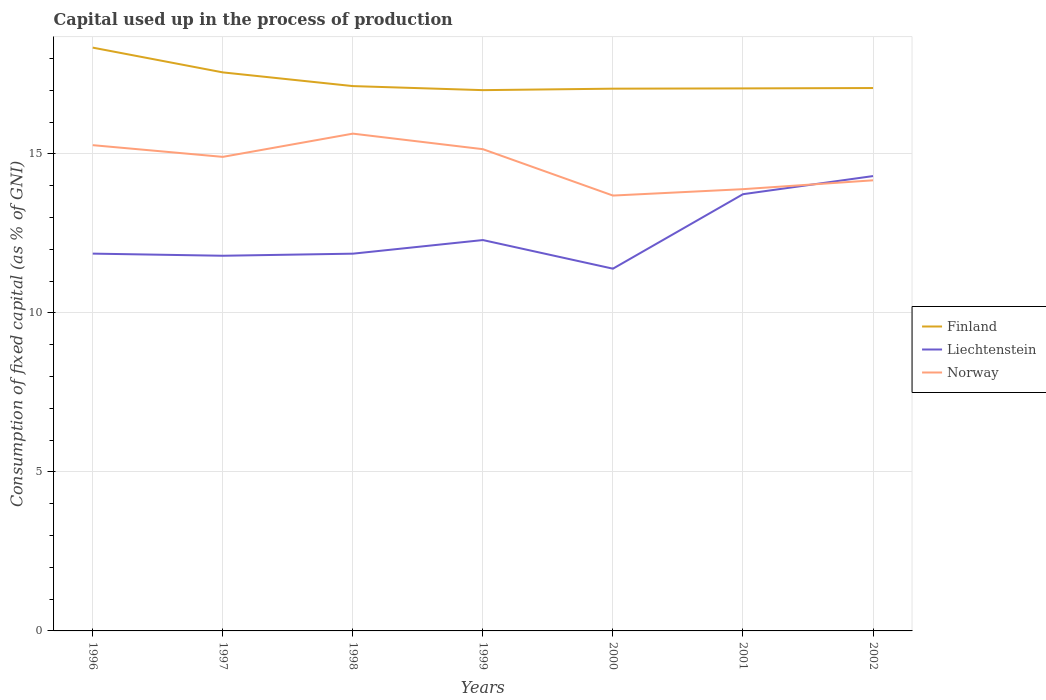Is the number of lines equal to the number of legend labels?
Your answer should be compact. Yes. Across all years, what is the maximum capital used up in the process of production in Finland?
Ensure brevity in your answer.  17.01. What is the total capital used up in the process of production in Liechtenstein in the graph?
Provide a short and direct response. -2.44. What is the difference between the highest and the second highest capital used up in the process of production in Norway?
Keep it short and to the point. 1.95. What is the difference between the highest and the lowest capital used up in the process of production in Liechtenstein?
Ensure brevity in your answer.  2. What is the difference between two consecutive major ticks on the Y-axis?
Provide a succinct answer. 5. Are the values on the major ticks of Y-axis written in scientific E-notation?
Make the answer very short. No. Does the graph contain any zero values?
Your response must be concise. No. Does the graph contain grids?
Provide a succinct answer. Yes. What is the title of the graph?
Your answer should be very brief. Capital used up in the process of production. What is the label or title of the X-axis?
Your answer should be compact. Years. What is the label or title of the Y-axis?
Give a very brief answer. Consumption of fixed capital (as % of GNI). What is the Consumption of fixed capital (as % of GNI) of Finland in 1996?
Provide a short and direct response. 18.34. What is the Consumption of fixed capital (as % of GNI) in Liechtenstein in 1996?
Give a very brief answer. 11.86. What is the Consumption of fixed capital (as % of GNI) in Norway in 1996?
Offer a terse response. 15.28. What is the Consumption of fixed capital (as % of GNI) in Finland in 1997?
Keep it short and to the point. 17.56. What is the Consumption of fixed capital (as % of GNI) of Liechtenstein in 1997?
Make the answer very short. 11.8. What is the Consumption of fixed capital (as % of GNI) of Norway in 1997?
Your answer should be very brief. 14.91. What is the Consumption of fixed capital (as % of GNI) of Finland in 1998?
Give a very brief answer. 17.13. What is the Consumption of fixed capital (as % of GNI) in Liechtenstein in 1998?
Provide a short and direct response. 11.86. What is the Consumption of fixed capital (as % of GNI) in Norway in 1998?
Make the answer very short. 15.64. What is the Consumption of fixed capital (as % of GNI) in Finland in 1999?
Provide a short and direct response. 17.01. What is the Consumption of fixed capital (as % of GNI) of Liechtenstein in 1999?
Ensure brevity in your answer.  12.29. What is the Consumption of fixed capital (as % of GNI) in Norway in 1999?
Offer a terse response. 15.15. What is the Consumption of fixed capital (as % of GNI) of Finland in 2000?
Offer a terse response. 17.05. What is the Consumption of fixed capital (as % of GNI) in Liechtenstein in 2000?
Ensure brevity in your answer.  11.39. What is the Consumption of fixed capital (as % of GNI) of Norway in 2000?
Make the answer very short. 13.69. What is the Consumption of fixed capital (as % of GNI) in Finland in 2001?
Your answer should be compact. 17.06. What is the Consumption of fixed capital (as % of GNI) of Liechtenstein in 2001?
Give a very brief answer. 13.73. What is the Consumption of fixed capital (as % of GNI) of Norway in 2001?
Ensure brevity in your answer.  13.89. What is the Consumption of fixed capital (as % of GNI) in Finland in 2002?
Offer a very short reply. 17.07. What is the Consumption of fixed capital (as % of GNI) of Liechtenstein in 2002?
Provide a short and direct response. 14.3. What is the Consumption of fixed capital (as % of GNI) in Norway in 2002?
Make the answer very short. 14.17. Across all years, what is the maximum Consumption of fixed capital (as % of GNI) of Finland?
Your answer should be very brief. 18.34. Across all years, what is the maximum Consumption of fixed capital (as % of GNI) in Liechtenstein?
Your answer should be very brief. 14.3. Across all years, what is the maximum Consumption of fixed capital (as % of GNI) of Norway?
Give a very brief answer. 15.64. Across all years, what is the minimum Consumption of fixed capital (as % of GNI) of Finland?
Make the answer very short. 17.01. Across all years, what is the minimum Consumption of fixed capital (as % of GNI) in Liechtenstein?
Give a very brief answer. 11.39. Across all years, what is the minimum Consumption of fixed capital (as % of GNI) in Norway?
Your answer should be very brief. 13.69. What is the total Consumption of fixed capital (as % of GNI) in Finland in the graph?
Offer a terse response. 121.23. What is the total Consumption of fixed capital (as % of GNI) in Liechtenstein in the graph?
Your response must be concise. 87.24. What is the total Consumption of fixed capital (as % of GNI) of Norway in the graph?
Provide a short and direct response. 102.72. What is the difference between the Consumption of fixed capital (as % of GNI) in Finland in 1996 and that in 1997?
Offer a very short reply. 0.78. What is the difference between the Consumption of fixed capital (as % of GNI) in Liechtenstein in 1996 and that in 1997?
Offer a very short reply. 0.07. What is the difference between the Consumption of fixed capital (as % of GNI) in Norway in 1996 and that in 1997?
Your response must be concise. 0.37. What is the difference between the Consumption of fixed capital (as % of GNI) of Finland in 1996 and that in 1998?
Your response must be concise. 1.21. What is the difference between the Consumption of fixed capital (as % of GNI) of Liechtenstein in 1996 and that in 1998?
Ensure brevity in your answer.  0. What is the difference between the Consumption of fixed capital (as % of GNI) in Norway in 1996 and that in 1998?
Give a very brief answer. -0.36. What is the difference between the Consumption of fixed capital (as % of GNI) of Finland in 1996 and that in 1999?
Give a very brief answer. 1.34. What is the difference between the Consumption of fixed capital (as % of GNI) of Liechtenstein in 1996 and that in 1999?
Keep it short and to the point. -0.43. What is the difference between the Consumption of fixed capital (as % of GNI) in Norway in 1996 and that in 1999?
Provide a short and direct response. 0.13. What is the difference between the Consumption of fixed capital (as % of GNI) in Finland in 1996 and that in 2000?
Give a very brief answer. 1.29. What is the difference between the Consumption of fixed capital (as % of GNI) in Liechtenstein in 1996 and that in 2000?
Your answer should be very brief. 0.47. What is the difference between the Consumption of fixed capital (as % of GNI) in Norway in 1996 and that in 2000?
Your answer should be compact. 1.58. What is the difference between the Consumption of fixed capital (as % of GNI) in Finland in 1996 and that in 2001?
Your response must be concise. 1.28. What is the difference between the Consumption of fixed capital (as % of GNI) in Liechtenstein in 1996 and that in 2001?
Offer a very short reply. -1.87. What is the difference between the Consumption of fixed capital (as % of GNI) in Norway in 1996 and that in 2001?
Give a very brief answer. 1.38. What is the difference between the Consumption of fixed capital (as % of GNI) in Finland in 1996 and that in 2002?
Your response must be concise. 1.27. What is the difference between the Consumption of fixed capital (as % of GNI) of Liechtenstein in 1996 and that in 2002?
Give a very brief answer. -2.44. What is the difference between the Consumption of fixed capital (as % of GNI) in Norway in 1996 and that in 2002?
Make the answer very short. 1.11. What is the difference between the Consumption of fixed capital (as % of GNI) of Finland in 1997 and that in 1998?
Provide a succinct answer. 0.43. What is the difference between the Consumption of fixed capital (as % of GNI) of Liechtenstein in 1997 and that in 1998?
Give a very brief answer. -0.07. What is the difference between the Consumption of fixed capital (as % of GNI) in Norway in 1997 and that in 1998?
Ensure brevity in your answer.  -0.73. What is the difference between the Consumption of fixed capital (as % of GNI) in Finland in 1997 and that in 1999?
Offer a very short reply. 0.56. What is the difference between the Consumption of fixed capital (as % of GNI) in Liechtenstein in 1997 and that in 1999?
Provide a succinct answer. -0.49. What is the difference between the Consumption of fixed capital (as % of GNI) in Norway in 1997 and that in 1999?
Offer a very short reply. -0.24. What is the difference between the Consumption of fixed capital (as % of GNI) in Finland in 1997 and that in 2000?
Provide a short and direct response. 0.51. What is the difference between the Consumption of fixed capital (as % of GNI) in Liechtenstein in 1997 and that in 2000?
Your answer should be compact. 0.41. What is the difference between the Consumption of fixed capital (as % of GNI) of Norway in 1997 and that in 2000?
Keep it short and to the point. 1.22. What is the difference between the Consumption of fixed capital (as % of GNI) in Finland in 1997 and that in 2001?
Give a very brief answer. 0.5. What is the difference between the Consumption of fixed capital (as % of GNI) in Liechtenstein in 1997 and that in 2001?
Give a very brief answer. -1.94. What is the difference between the Consumption of fixed capital (as % of GNI) of Norway in 1997 and that in 2001?
Your answer should be very brief. 1.02. What is the difference between the Consumption of fixed capital (as % of GNI) of Finland in 1997 and that in 2002?
Keep it short and to the point. 0.49. What is the difference between the Consumption of fixed capital (as % of GNI) of Liechtenstein in 1997 and that in 2002?
Your response must be concise. -2.51. What is the difference between the Consumption of fixed capital (as % of GNI) of Norway in 1997 and that in 2002?
Your answer should be compact. 0.74. What is the difference between the Consumption of fixed capital (as % of GNI) of Finland in 1998 and that in 1999?
Offer a very short reply. 0.13. What is the difference between the Consumption of fixed capital (as % of GNI) of Liechtenstein in 1998 and that in 1999?
Your response must be concise. -0.43. What is the difference between the Consumption of fixed capital (as % of GNI) of Norway in 1998 and that in 1999?
Give a very brief answer. 0.49. What is the difference between the Consumption of fixed capital (as % of GNI) in Finland in 1998 and that in 2000?
Make the answer very short. 0.08. What is the difference between the Consumption of fixed capital (as % of GNI) in Liechtenstein in 1998 and that in 2000?
Provide a succinct answer. 0.47. What is the difference between the Consumption of fixed capital (as % of GNI) in Norway in 1998 and that in 2000?
Your answer should be very brief. 1.95. What is the difference between the Consumption of fixed capital (as % of GNI) in Finland in 1998 and that in 2001?
Offer a terse response. 0.07. What is the difference between the Consumption of fixed capital (as % of GNI) in Liechtenstein in 1998 and that in 2001?
Keep it short and to the point. -1.87. What is the difference between the Consumption of fixed capital (as % of GNI) of Norway in 1998 and that in 2001?
Your answer should be compact. 1.75. What is the difference between the Consumption of fixed capital (as % of GNI) in Finland in 1998 and that in 2002?
Provide a short and direct response. 0.06. What is the difference between the Consumption of fixed capital (as % of GNI) of Liechtenstein in 1998 and that in 2002?
Ensure brevity in your answer.  -2.44. What is the difference between the Consumption of fixed capital (as % of GNI) of Norway in 1998 and that in 2002?
Provide a succinct answer. 1.47. What is the difference between the Consumption of fixed capital (as % of GNI) of Finland in 1999 and that in 2000?
Your answer should be very brief. -0.05. What is the difference between the Consumption of fixed capital (as % of GNI) in Norway in 1999 and that in 2000?
Your response must be concise. 1.46. What is the difference between the Consumption of fixed capital (as % of GNI) of Finland in 1999 and that in 2001?
Offer a terse response. -0.05. What is the difference between the Consumption of fixed capital (as % of GNI) in Liechtenstein in 1999 and that in 2001?
Your response must be concise. -1.44. What is the difference between the Consumption of fixed capital (as % of GNI) in Norway in 1999 and that in 2001?
Offer a terse response. 1.26. What is the difference between the Consumption of fixed capital (as % of GNI) of Finland in 1999 and that in 2002?
Provide a succinct answer. -0.07. What is the difference between the Consumption of fixed capital (as % of GNI) of Liechtenstein in 1999 and that in 2002?
Ensure brevity in your answer.  -2.01. What is the difference between the Consumption of fixed capital (as % of GNI) of Finland in 2000 and that in 2001?
Your answer should be compact. -0.01. What is the difference between the Consumption of fixed capital (as % of GNI) of Liechtenstein in 2000 and that in 2001?
Your answer should be compact. -2.34. What is the difference between the Consumption of fixed capital (as % of GNI) of Norway in 2000 and that in 2001?
Offer a terse response. -0.2. What is the difference between the Consumption of fixed capital (as % of GNI) of Finland in 2000 and that in 2002?
Your answer should be very brief. -0.02. What is the difference between the Consumption of fixed capital (as % of GNI) of Liechtenstein in 2000 and that in 2002?
Your answer should be compact. -2.91. What is the difference between the Consumption of fixed capital (as % of GNI) of Norway in 2000 and that in 2002?
Make the answer very short. -0.48. What is the difference between the Consumption of fixed capital (as % of GNI) of Finland in 2001 and that in 2002?
Offer a very short reply. -0.01. What is the difference between the Consumption of fixed capital (as % of GNI) in Liechtenstein in 2001 and that in 2002?
Make the answer very short. -0.57. What is the difference between the Consumption of fixed capital (as % of GNI) in Norway in 2001 and that in 2002?
Provide a succinct answer. -0.28. What is the difference between the Consumption of fixed capital (as % of GNI) in Finland in 1996 and the Consumption of fixed capital (as % of GNI) in Liechtenstein in 1997?
Provide a short and direct response. 6.54. What is the difference between the Consumption of fixed capital (as % of GNI) in Finland in 1996 and the Consumption of fixed capital (as % of GNI) in Norway in 1997?
Offer a terse response. 3.44. What is the difference between the Consumption of fixed capital (as % of GNI) in Liechtenstein in 1996 and the Consumption of fixed capital (as % of GNI) in Norway in 1997?
Your answer should be compact. -3.04. What is the difference between the Consumption of fixed capital (as % of GNI) in Finland in 1996 and the Consumption of fixed capital (as % of GNI) in Liechtenstein in 1998?
Your answer should be compact. 6.48. What is the difference between the Consumption of fixed capital (as % of GNI) in Finland in 1996 and the Consumption of fixed capital (as % of GNI) in Norway in 1998?
Give a very brief answer. 2.7. What is the difference between the Consumption of fixed capital (as % of GNI) of Liechtenstein in 1996 and the Consumption of fixed capital (as % of GNI) of Norway in 1998?
Ensure brevity in your answer.  -3.77. What is the difference between the Consumption of fixed capital (as % of GNI) of Finland in 1996 and the Consumption of fixed capital (as % of GNI) of Liechtenstein in 1999?
Offer a terse response. 6.05. What is the difference between the Consumption of fixed capital (as % of GNI) of Finland in 1996 and the Consumption of fixed capital (as % of GNI) of Norway in 1999?
Give a very brief answer. 3.19. What is the difference between the Consumption of fixed capital (as % of GNI) of Liechtenstein in 1996 and the Consumption of fixed capital (as % of GNI) of Norway in 1999?
Keep it short and to the point. -3.28. What is the difference between the Consumption of fixed capital (as % of GNI) of Finland in 1996 and the Consumption of fixed capital (as % of GNI) of Liechtenstein in 2000?
Provide a short and direct response. 6.95. What is the difference between the Consumption of fixed capital (as % of GNI) in Finland in 1996 and the Consumption of fixed capital (as % of GNI) in Norway in 2000?
Give a very brief answer. 4.65. What is the difference between the Consumption of fixed capital (as % of GNI) of Liechtenstein in 1996 and the Consumption of fixed capital (as % of GNI) of Norway in 2000?
Provide a succinct answer. -1.83. What is the difference between the Consumption of fixed capital (as % of GNI) in Finland in 1996 and the Consumption of fixed capital (as % of GNI) in Liechtenstein in 2001?
Keep it short and to the point. 4.61. What is the difference between the Consumption of fixed capital (as % of GNI) in Finland in 1996 and the Consumption of fixed capital (as % of GNI) in Norway in 2001?
Your answer should be very brief. 4.45. What is the difference between the Consumption of fixed capital (as % of GNI) of Liechtenstein in 1996 and the Consumption of fixed capital (as % of GNI) of Norway in 2001?
Ensure brevity in your answer.  -2.03. What is the difference between the Consumption of fixed capital (as % of GNI) in Finland in 1996 and the Consumption of fixed capital (as % of GNI) in Liechtenstein in 2002?
Give a very brief answer. 4.04. What is the difference between the Consumption of fixed capital (as % of GNI) of Finland in 1996 and the Consumption of fixed capital (as % of GNI) of Norway in 2002?
Your response must be concise. 4.17. What is the difference between the Consumption of fixed capital (as % of GNI) of Liechtenstein in 1996 and the Consumption of fixed capital (as % of GNI) of Norway in 2002?
Ensure brevity in your answer.  -2.31. What is the difference between the Consumption of fixed capital (as % of GNI) in Finland in 1997 and the Consumption of fixed capital (as % of GNI) in Liechtenstein in 1998?
Provide a short and direct response. 5.7. What is the difference between the Consumption of fixed capital (as % of GNI) in Finland in 1997 and the Consumption of fixed capital (as % of GNI) in Norway in 1998?
Provide a short and direct response. 1.93. What is the difference between the Consumption of fixed capital (as % of GNI) of Liechtenstein in 1997 and the Consumption of fixed capital (as % of GNI) of Norway in 1998?
Your answer should be very brief. -3.84. What is the difference between the Consumption of fixed capital (as % of GNI) of Finland in 1997 and the Consumption of fixed capital (as % of GNI) of Liechtenstein in 1999?
Keep it short and to the point. 5.27. What is the difference between the Consumption of fixed capital (as % of GNI) in Finland in 1997 and the Consumption of fixed capital (as % of GNI) in Norway in 1999?
Your response must be concise. 2.42. What is the difference between the Consumption of fixed capital (as % of GNI) in Liechtenstein in 1997 and the Consumption of fixed capital (as % of GNI) in Norway in 1999?
Give a very brief answer. -3.35. What is the difference between the Consumption of fixed capital (as % of GNI) of Finland in 1997 and the Consumption of fixed capital (as % of GNI) of Liechtenstein in 2000?
Offer a terse response. 6.17. What is the difference between the Consumption of fixed capital (as % of GNI) of Finland in 1997 and the Consumption of fixed capital (as % of GNI) of Norway in 2000?
Provide a short and direct response. 3.87. What is the difference between the Consumption of fixed capital (as % of GNI) of Liechtenstein in 1997 and the Consumption of fixed capital (as % of GNI) of Norway in 2000?
Your answer should be very brief. -1.89. What is the difference between the Consumption of fixed capital (as % of GNI) in Finland in 1997 and the Consumption of fixed capital (as % of GNI) in Liechtenstein in 2001?
Provide a succinct answer. 3.83. What is the difference between the Consumption of fixed capital (as % of GNI) of Finland in 1997 and the Consumption of fixed capital (as % of GNI) of Norway in 2001?
Make the answer very short. 3.67. What is the difference between the Consumption of fixed capital (as % of GNI) of Liechtenstein in 1997 and the Consumption of fixed capital (as % of GNI) of Norway in 2001?
Keep it short and to the point. -2.09. What is the difference between the Consumption of fixed capital (as % of GNI) in Finland in 1997 and the Consumption of fixed capital (as % of GNI) in Liechtenstein in 2002?
Provide a short and direct response. 3.26. What is the difference between the Consumption of fixed capital (as % of GNI) in Finland in 1997 and the Consumption of fixed capital (as % of GNI) in Norway in 2002?
Ensure brevity in your answer.  3.39. What is the difference between the Consumption of fixed capital (as % of GNI) of Liechtenstein in 1997 and the Consumption of fixed capital (as % of GNI) of Norway in 2002?
Give a very brief answer. -2.37. What is the difference between the Consumption of fixed capital (as % of GNI) of Finland in 1998 and the Consumption of fixed capital (as % of GNI) of Liechtenstein in 1999?
Give a very brief answer. 4.84. What is the difference between the Consumption of fixed capital (as % of GNI) in Finland in 1998 and the Consumption of fixed capital (as % of GNI) in Norway in 1999?
Your answer should be compact. 1.98. What is the difference between the Consumption of fixed capital (as % of GNI) of Liechtenstein in 1998 and the Consumption of fixed capital (as % of GNI) of Norway in 1999?
Your response must be concise. -3.29. What is the difference between the Consumption of fixed capital (as % of GNI) of Finland in 1998 and the Consumption of fixed capital (as % of GNI) of Liechtenstein in 2000?
Offer a very short reply. 5.74. What is the difference between the Consumption of fixed capital (as % of GNI) of Finland in 1998 and the Consumption of fixed capital (as % of GNI) of Norway in 2000?
Keep it short and to the point. 3.44. What is the difference between the Consumption of fixed capital (as % of GNI) in Liechtenstein in 1998 and the Consumption of fixed capital (as % of GNI) in Norway in 2000?
Provide a short and direct response. -1.83. What is the difference between the Consumption of fixed capital (as % of GNI) in Finland in 1998 and the Consumption of fixed capital (as % of GNI) in Liechtenstein in 2001?
Offer a very short reply. 3.4. What is the difference between the Consumption of fixed capital (as % of GNI) in Finland in 1998 and the Consumption of fixed capital (as % of GNI) in Norway in 2001?
Offer a very short reply. 3.24. What is the difference between the Consumption of fixed capital (as % of GNI) in Liechtenstein in 1998 and the Consumption of fixed capital (as % of GNI) in Norway in 2001?
Give a very brief answer. -2.03. What is the difference between the Consumption of fixed capital (as % of GNI) of Finland in 1998 and the Consumption of fixed capital (as % of GNI) of Liechtenstein in 2002?
Provide a succinct answer. 2.83. What is the difference between the Consumption of fixed capital (as % of GNI) in Finland in 1998 and the Consumption of fixed capital (as % of GNI) in Norway in 2002?
Keep it short and to the point. 2.96. What is the difference between the Consumption of fixed capital (as % of GNI) of Liechtenstein in 1998 and the Consumption of fixed capital (as % of GNI) of Norway in 2002?
Provide a short and direct response. -2.31. What is the difference between the Consumption of fixed capital (as % of GNI) in Finland in 1999 and the Consumption of fixed capital (as % of GNI) in Liechtenstein in 2000?
Make the answer very short. 5.61. What is the difference between the Consumption of fixed capital (as % of GNI) in Finland in 1999 and the Consumption of fixed capital (as % of GNI) in Norway in 2000?
Provide a short and direct response. 3.32. What is the difference between the Consumption of fixed capital (as % of GNI) of Liechtenstein in 1999 and the Consumption of fixed capital (as % of GNI) of Norway in 2000?
Keep it short and to the point. -1.4. What is the difference between the Consumption of fixed capital (as % of GNI) in Finland in 1999 and the Consumption of fixed capital (as % of GNI) in Liechtenstein in 2001?
Your answer should be very brief. 3.27. What is the difference between the Consumption of fixed capital (as % of GNI) of Finland in 1999 and the Consumption of fixed capital (as % of GNI) of Norway in 2001?
Provide a short and direct response. 3.11. What is the difference between the Consumption of fixed capital (as % of GNI) of Liechtenstein in 1999 and the Consumption of fixed capital (as % of GNI) of Norway in 2001?
Keep it short and to the point. -1.6. What is the difference between the Consumption of fixed capital (as % of GNI) in Finland in 1999 and the Consumption of fixed capital (as % of GNI) in Liechtenstein in 2002?
Keep it short and to the point. 2.7. What is the difference between the Consumption of fixed capital (as % of GNI) of Finland in 1999 and the Consumption of fixed capital (as % of GNI) of Norway in 2002?
Give a very brief answer. 2.84. What is the difference between the Consumption of fixed capital (as % of GNI) of Liechtenstein in 1999 and the Consumption of fixed capital (as % of GNI) of Norway in 2002?
Your answer should be very brief. -1.88. What is the difference between the Consumption of fixed capital (as % of GNI) of Finland in 2000 and the Consumption of fixed capital (as % of GNI) of Liechtenstein in 2001?
Offer a terse response. 3.32. What is the difference between the Consumption of fixed capital (as % of GNI) in Finland in 2000 and the Consumption of fixed capital (as % of GNI) in Norway in 2001?
Provide a short and direct response. 3.16. What is the difference between the Consumption of fixed capital (as % of GNI) of Liechtenstein in 2000 and the Consumption of fixed capital (as % of GNI) of Norway in 2001?
Your response must be concise. -2.5. What is the difference between the Consumption of fixed capital (as % of GNI) in Finland in 2000 and the Consumption of fixed capital (as % of GNI) in Liechtenstein in 2002?
Offer a terse response. 2.75. What is the difference between the Consumption of fixed capital (as % of GNI) of Finland in 2000 and the Consumption of fixed capital (as % of GNI) of Norway in 2002?
Keep it short and to the point. 2.88. What is the difference between the Consumption of fixed capital (as % of GNI) of Liechtenstein in 2000 and the Consumption of fixed capital (as % of GNI) of Norway in 2002?
Offer a terse response. -2.78. What is the difference between the Consumption of fixed capital (as % of GNI) of Finland in 2001 and the Consumption of fixed capital (as % of GNI) of Liechtenstein in 2002?
Provide a short and direct response. 2.76. What is the difference between the Consumption of fixed capital (as % of GNI) in Finland in 2001 and the Consumption of fixed capital (as % of GNI) in Norway in 2002?
Offer a very short reply. 2.89. What is the difference between the Consumption of fixed capital (as % of GNI) in Liechtenstein in 2001 and the Consumption of fixed capital (as % of GNI) in Norway in 2002?
Keep it short and to the point. -0.44. What is the average Consumption of fixed capital (as % of GNI) of Finland per year?
Your answer should be very brief. 17.32. What is the average Consumption of fixed capital (as % of GNI) of Liechtenstein per year?
Provide a short and direct response. 12.46. What is the average Consumption of fixed capital (as % of GNI) in Norway per year?
Keep it short and to the point. 14.67. In the year 1996, what is the difference between the Consumption of fixed capital (as % of GNI) in Finland and Consumption of fixed capital (as % of GNI) in Liechtenstein?
Your answer should be very brief. 6.48. In the year 1996, what is the difference between the Consumption of fixed capital (as % of GNI) in Finland and Consumption of fixed capital (as % of GNI) in Norway?
Offer a very short reply. 3.07. In the year 1996, what is the difference between the Consumption of fixed capital (as % of GNI) in Liechtenstein and Consumption of fixed capital (as % of GNI) in Norway?
Keep it short and to the point. -3.41. In the year 1997, what is the difference between the Consumption of fixed capital (as % of GNI) of Finland and Consumption of fixed capital (as % of GNI) of Liechtenstein?
Give a very brief answer. 5.77. In the year 1997, what is the difference between the Consumption of fixed capital (as % of GNI) in Finland and Consumption of fixed capital (as % of GNI) in Norway?
Your answer should be very brief. 2.66. In the year 1997, what is the difference between the Consumption of fixed capital (as % of GNI) in Liechtenstein and Consumption of fixed capital (as % of GNI) in Norway?
Your answer should be very brief. -3.11. In the year 1998, what is the difference between the Consumption of fixed capital (as % of GNI) in Finland and Consumption of fixed capital (as % of GNI) in Liechtenstein?
Provide a succinct answer. 5.27. In the year 1998, what is the difference between the Consumption of fixed capital (as % of GNI) of Finland and Consumption of fixed capital (as % of GNI) of Norway?
Give a very brief answer. 1.5. In the year 1998, what is the difference between the Consumption of fixed capital (as % of GNI) in Liechtenstein and Consumption of fixed capital (as % of GNI) in Norway?
Your answer should be compact. -3.77. In the year 1999, what is the difference between the Consumption of fixed capital (as % of GNI) in Finland and Consumption of fixed capital (as % of GNI) in Liechtenstein?
Provide a succinct answer. 4.71. In the year 1999, what is the difference between the Consumption of fixed capital (as % of GNI) in Finland and Consumption of fixed capital (as % of GNI) in Norway?
Keep it short and to the point. 1.86. In the year 1999, what is the difference between the Consumption of fixed capital (as % of GNI) of Liechtenstein and Consumption of fixed capital (as % of GNI) of Norway?
Provide a succinct answer. -2.86. In the year 2000, what is the difference between the Consumption of fixed capital (as % of GNI) of Finland and Consumption of fixed capital (as % of GNI) of Liechtenstein?
Offer a terse response. 5.66. In the year 2000, what is the difference between the Consumption of fixed capital (as % of GNI) in Finland and Consumption of fixed capital (as % of GNI) in Norway?
Make the answer very short. 3.36. In the year 2000, what is the difference between the Consumption of fixed capital (as % of GNI) in Liechtenstein and Consumption of fixed capital (as % of GNI) in Norway?
Ensure brevity in your answer.  -2.3. In the year 2001, what is the difference between the Consumption of fixed capital (as % of GNI) of Finland and Consumption of fixed capital (as % of GNI) of Liechtenstein?
Make the answer very short. 3.33. In the year 2001, what is the difference between the Consumption of fixed capital (as % of GNI) of Finland and Consumption of fixed capital (as % of GNI) of Norway?
Your answer should be very brief. 3.17. In the year 2001, what is the difference between the Consumption of fixed capital (as % of GNI) in Liechtenstein and Consumption of fixed capital (as % of GNI) in Norway?
Make the answer very short. -0.16. In the year 2002, what is the difference between the Consumption of fixed capital (as % of GNI) in Finland and Consumption of fixed capital (as % of GNI) in Liechtenstein?
Provide a succinct answer. 2.77. In the year 2002, what is the difference between the Consumption of fixed capital (as % of GNI) in Finland and Consumption of fixed capital (as % of GNI) in Norway?
Make the answer very short. 2.9. In the year 2002, what is the difference between the Consumption of fixed capital (as % of GNI) in Liechtenstein and Consumption of fixed capital (as % of GNI) in Norway?
Make the answer very short. 0.13. What is the ratio of the Consumption of fixed capital (as % of GNI) of Finland in 1996 to that in 1997?
Your answer should be very brief. 1.04. What is the ratio of the Consumption of fixed capital (as % of GNI) of Liechtenstein in 1996 to that in 1997?
Your answer should be very brief. 1.01. What is the ratio of the Consumption of fixed capital (as % of GNI) in Norway in 1996 to that in 1997?
Offer a terse response. 1.02. What is the ratio of the Consumption of fixed capital (as % of GNI) in Finland in 1996 to that in 1998?
Your response must be concise. 1.07. What is the ratio of the Consumption of fixed capital (as % of GNI) of Norway in 1996 to that in 1998?
Keep it short and to the point. 0.98. What is the ratio of the Consumption of fixed capital (as % of GNI) in Finland in 1996 to that in 1999?
Provide a succinct answer. 1.08. What is the ratio of the Consumption of fixed capital (as % of GNI) of Liechtenstein in 1996 to that in 1999?
Your answer should be compact. 0.97. What is the ratio of the Consumption of fixed capital (as % of GNI) of Norway in 1996 to that in 1999?
Your answer should be compact. 1.01. What is the ratio of the Consumption of fixed capital (as % of GNI) of Finland in 1996 to that in 2000?
Give a very brief answer. 1.08. What is the ratio of the Consumption of fixed capital (as % of GNI) in Liechtenstein in 1996 to that in 2000?
Give a very brief answer. 1.04. What is the ratio of the Consumption of fixed capital (as % of GNI) of Norway in 1996 to that in 2000?
Give a very brief answer. 1.12. What is the ratio of the Consumption of fixed capital (as % of GNI) of Finland in 1996 to that in 2001?
Your answer should be compact. 1.08. What is the ratio of the Consumption of fixed capital (as % of GNI) of Liechtenstein in 1996 to that in 2001?
Your response must be concise. 0.86. What is the ratio of the Consumption of fixed capital (as % of GNI) in Norway in 1996 to that in 2001?
Provide a succinct answer. 1.1. What is the ratio of the Consumption of fixed capital (as % of GNI) in Finland in 1996 to that in 2002?
Provide a short and direct response. 1.07. What is the ratio of the Consumption of fixed capital (as % of GNI) of Liechtenstein in 1996 to that in 2002?
Your response must be concise. 0.83. What is the ratio of the Consumption of fixed capital (as % of GNI) of Norway in 1996 to that in 2002?
Provide a short and direct response. 1.08. What is the ratio of the Consumption of fixed capital (as % of GNI) of Finland in 1997 to that in 1998?
Offer a terse response. 1.03. What is the ratio of the Consumption of fixed capital (as % of GNI) in Norway in 1997 to that in 1998?
Make the answer very short. 0.95. What is the ratio of the Consumption of fixed capital (as % of GNI) in Finland in 1997 to that in 1999?
Your answer should be very brief. 1.03. What is the ratio of the Consumption of fixed capital (as % of GNI) in Liechtenstein in 1997 to that in 1999?
Give a very brief answer. 0.96. What is the ratio of the Consumption of fixed capital (as % of GNI) of Finland in 1997 to that in 2000?
Your response must be concise. 1.03. What is the ratio of the Consumption of fixed capital (as % of GNI) in Liechtenstein in 1997 to that in 2000?
Keep it short and to the point. 1.04. What is the ratio of the Consumption of fixed capital (as % of GNI) of Norway in 1997 to that in 2000?
Your answer should be compact. 1.09. What is the ratio of the Consumption of fixed capital (as % of GNI) of Finland in 1997 to that in 2001?
Give a very brief answer. 1.03. What is the ratio of the Consumption of fixed capital (as % of GNI) of Liechtenstein in 1997 to that in 2001?
Offer a very short reply. 0.86. What is the ratio of the Consumption of fixed capital (as % of GNI) of Norway in 1997 to that in 2001?
Ensure brevity in your answer.  1.07. What is the ratio of the Consumption of fixed capital (as % of GNI) in Finland in 1997 to that in 2002?
Your answer should be compact. 1.03. What is the ratio of the Consumption of fixed capital (as % of GNI) in Liechtenstein in 1997 to that in 2002?
Offer a very short reply. 0.82. What is the ratio of the Consumption of fixed capital (as % of GNI) in Norway in 1997 to that in 2002?
Ensure brevity in your answer.  1.05. What is the ratio of the Consumption of fixed capital (as % of GNI) of Finland in 1998 to that in 1999?
Your answer should be compact. 1.01. What is the ratio of the Consumption of fixed capital (as % of GNI) of Liechtenstein in 1998 to that in 1999?
Keep it short and to the point. 0.97. What is the ratio of the Consumption of fixed capital (as % of GNI) of Norway in 1998 to that in 1999?
Keep it short and to the point. 1.03. What is the ratio of the Consumption of fixed capital (as % of GNI) of Liechtenstein in 1998 to that in 2000?
Offer a terse response. 1.04. What is the ratio of the Consumption of fixed capital (as % of GNI) in Norway in 1998 to that in 2000?
Provide a short and direct response. 1.14. What is the ratio of the Consumption of fixed capital (as % of GNI) in Finland in 1998 to that in 2001?
Your answer should be compact. 1. What is the ratio of the Consumption of fixed capital (as % of GNI) in Liechtenstein in 1998 to that in 2001?
Provide a succinct answer. 0.86. What is the ratio of the Consumption of fixed capital (as % of GNI) in Norway in 1998 to that in 2001?
Your answer should be compact. 1.13. What is the ratio of the Consumption of fixed capital (as % of GNI) of Finland in 1998 to that in 2002?
Make the answer very short. 1. What is the ratio of the Consumption of fixed capital (as % of GNI) in Liechtenstein in 1998 to that in 2002?
Keep it short and to the point. 0.83. What is the ratio of the Consumption of fixed capital (as % of GNI) of Norway in 1998 to that in 2002?
Your answer should be compact. 1.1. What is the ratio of the Consumption of fixed capital (as % of GNI) in Liechtenstein in 1999 to that in 2000?
Provide a short and direct response. 1.08. What is the ratio of the Consumption of fixed capital (as % of GNI) in Norway in 1999 to that in 2000?
Provide a short and direct response. 1.11. What is the ratio of the Consumption of fixed capital (as % of GNI) of Finland in 1999 to that in 2001?
Make the answer very short. 1. What is the ratio of the Consumption of fixed capital (as % of GNI) in Liechtenstein in 1999 to that in 2001?
Your answer should be compact. 0.9. What is the ratio of the Consumption of fixed capital (as % of GNI) in Norway in 1999 to that in 2001?
Provide a short and direct response. 1.09. What is the ratio of the Consumption of fixed capital (as % of GNI) of Liechtenstein in 1999 to that in 2002?
Your response must be concise. 0.86. What is the ratio of the Consumption of fixed capital (as % of GNI) in Norway in 1999 to that in 2002?
Your answer should be compact. 1.07. What is the ratio of the Consumption of fixed capital (as % of GNI) of Finland in 2000 to that in 2001?
Offer a terse response. 1. What is the ratio of the Consumption of fixed capital (as % of GNI) in Liechtenstein in 2000 to that in 2001?
Keep it short and to the point. 0.83. What is the ratio of the Consumption of fixed capital (as % of GNI) of Norway in 2000 to that in 2001?
Ensure brevity in your answer.  0.99. What is the ratio of the Consumption of fixed capital (as % of GNI) of Finland in 2000 to that in 2002?
Give a very brief answer. 1. What is the ratio of the Consumption of fixed capital (as % of GNI) of Liechtenstein in 2000 to that in 2002?
Make the answer very short. 0.8. What is the ratio of the Consumption of fixed capital (as % of GNI) in Norway in 2000 to that in 2002?
Provide a succinct answer. 0.97. What is the ratio of the Consumption of fixed capital (as % of GNI) in Finland in 2001 to that in 2002?
Offer a very short reply. 1. What is the ratio of the Consumption of fixed capital (as % of GNI) of Liechtenstein in 2001 to that in 2002?
Give a very brief answer. 0.96. What is the ratio of the Consumption of fixed capital (as % of GNI) of Norway in 2001 to that in 2002?
Provide a succinct answer. 0.98. What is the difference between the highest and the second highest Consumption of fixed capital (as % of GNI) in Finland?
Give a very brief answer. 0.78. What is the difference between the highest and the second highest Consumption of fixed capital (as % of GNI) in Liechtenstein?
Offer a terse response. 0.57. What is the difference between the highest and the second highest Consumption of fixed capital (as % of GNI) in Norway?
Provide a short and direct response. 0.36. What is the difference between the highest and the lowest Consumption of fixed capital (as % of GNI) of Finland?
Your answer should be very brief. 1.34. What is the difference between the highest and the lowest Consumption of fixed capital (as % of GNI) in Liechtenstein?
Make the answer very short. 2.91. What is the difference between the highest and the lowest Consumption of fixed capital (as % of GNI) of Norway?
Give a very brief answer. 1.95. 